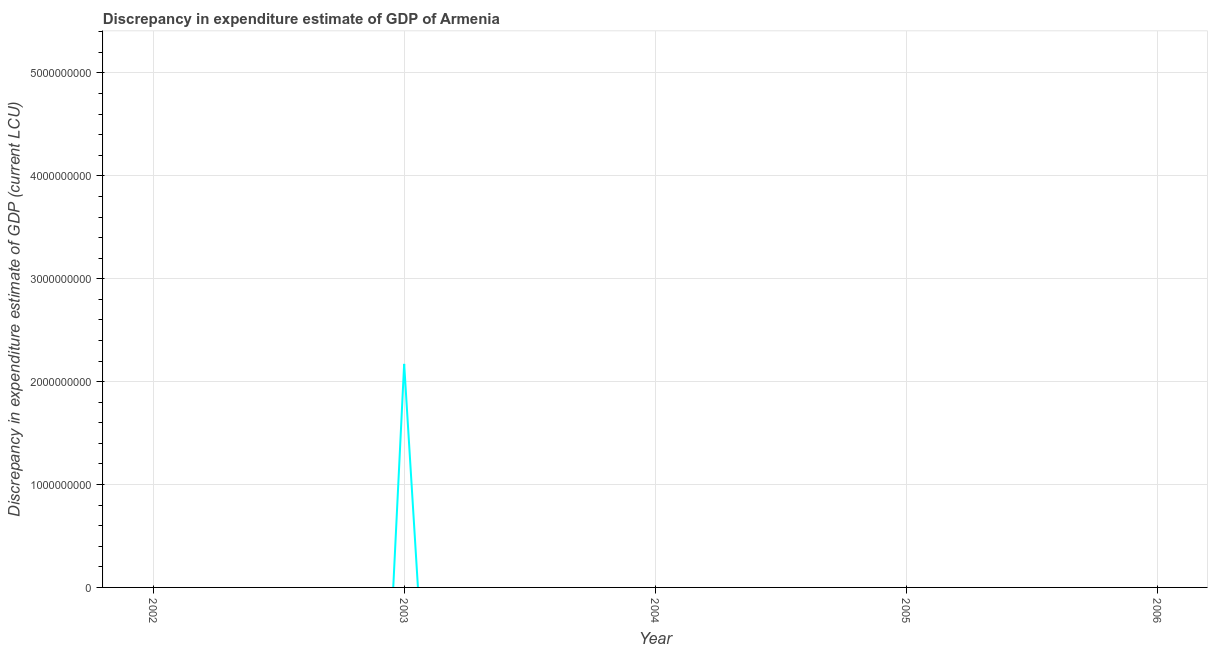Across all years, what is the maximum discrepancy in expenditure estimate of gdp?
Give a very brief answer. 2.17e+09. Across all years, what is the minimum discrepancy in expenditure estimate of gdp?
Your answer should be very brief. 0. What is the sum of the discrepancy in expenditure estimate of gdp?
Offer a terse response. 2.17e+09. What is the average discrepancy in expenditure estimate of gdp per year?
Offer a terse response. 4.34e+08. What is the median discrepancy in expenditure estimate of gdp?
Offer a very short reply. 0. What is the difference between the highest and the lowest discrepancy in expenditure estimate of gdp?
Ensure brevity in your answer.  2.17e+09. In how many years, is the discrepancy in expenditure estimate of gdp greater than the average discrepancy in expenditure estimate of gdp taken over all years?
Give a very brief answer. 1. Does the discrepancy in expenditure estimate of gdp monotonically increase over the years?
Ensure brevity in your answer.  No. How many lines are there?
Keep it short and to the point. 1. How many years are there in the graph?
Provide a succinct answer. 5. What is the difference between two consecutive major ticks on the Y-axis?
Your answer should be very brief. 1.00e+09. Does the graph contain grids?
Offer a terse response. Yes. What is the title of the graph?
Give a very brief answer. Discrepancy in expenditure estimate of GDP of Armenia. What is the label or title of the Y-axis?
Ensure brevity in your answer.  Discrepancy in expenditure estimate of GDP (current LCU). What is the Discrepancy in expenditure estimate of GDP (current LCU) of 2003?
Keep it short and to the point. 2.17e+09. What is the Discrepancy in expenditure estimate of GDP (current LCU) in 2005?
Offer a very short reply. 0. What is the Discrepancy in expenditure estimate of GDP (current LCU) of 2006?
Offer a terse response. 0. 